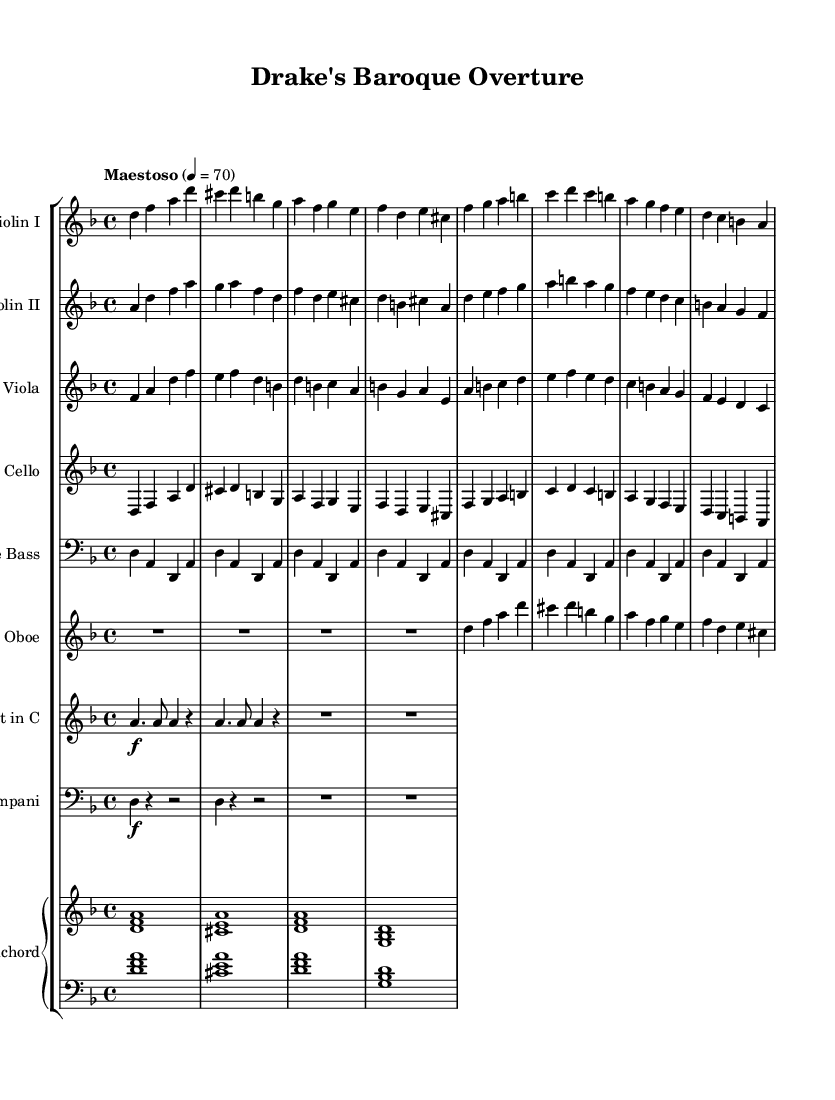What is the key signature of this music? The key signature has two flats indicated by the presence of B♭ and E♭. Therefore, the key signature is D minor.
Answer: D minor What is the time signature of this music? The time signature is located at the beginning of the staff, showing a quarter note gets one beat, and there are four beats per measure. Hence, the time signature is 4/4.
Answer: 4/4 What is the tempo marking of this piece? The tempo marking is placed above the staff, indicating the speed at which the music should be played. It reads "Maestoso," which means to play in a majestic and stately manner, with a tempo of 70 beats per minute.
Answer: Maestoso How many instruments are in the score? By examining the score, we can count the number of distinct staves. There are nine staves representing different instruments, including violins, viola, cello, double bass, oboe, trumpet, timpani, and harpsichord.
Answer: Nine What is the texture of the overture indicated by the instrumental arrangement? The arrangement includes a combination of strings and woodwinds, supported by a harpsichord as the continuo, leading to a rich, multi-layered orchestral texture, typical of Baroque-era music.
Answer: Polyphonic Which instrument plays the highest pitch in this piece? The highest pitch is typically found in the Violin I part, where it reaches the notes above middle C. In this case, Violin I plays the highest notes among the listed instruments.
Answer: Violin I 